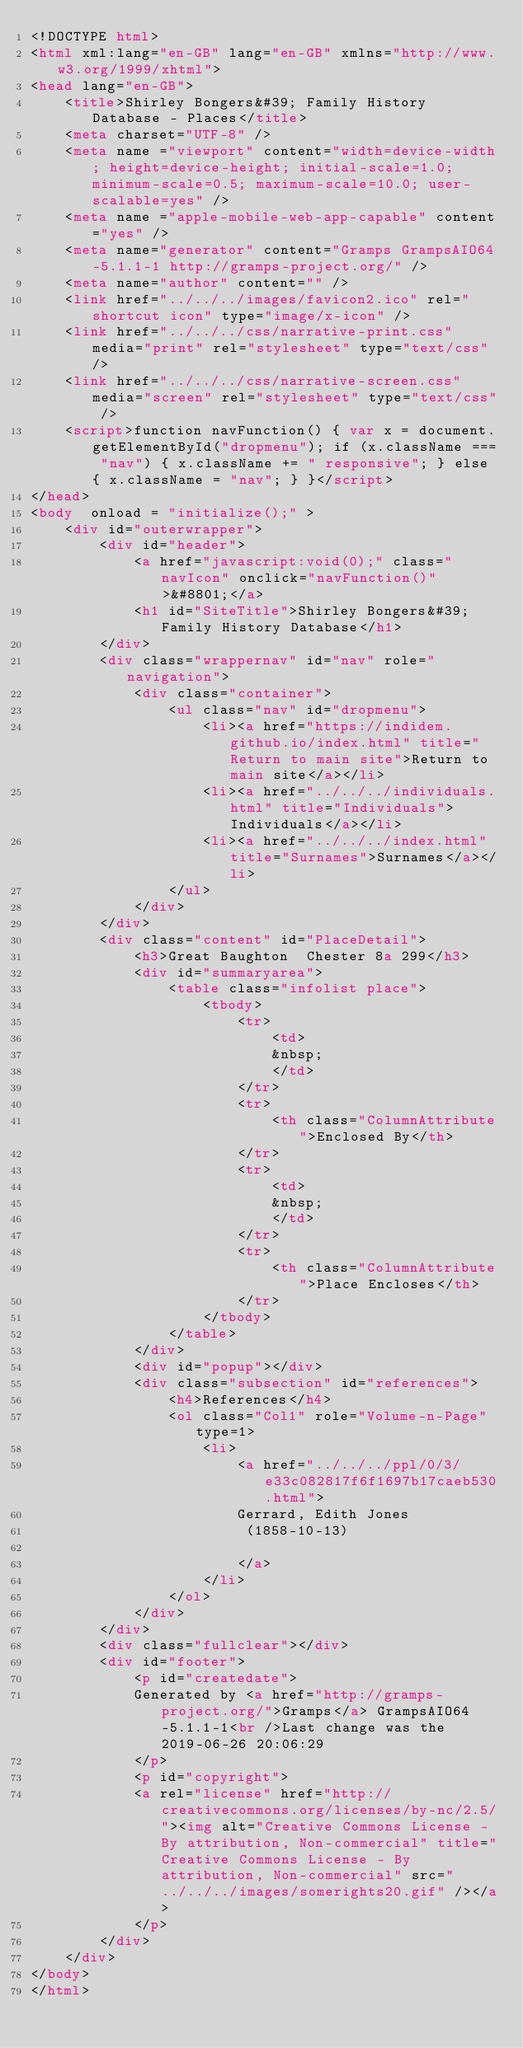Convert code to text. <code><loc_0><loc_0><loc_500><loc_500><_HTML_><!DOCTYPE html>
<html xml:lang="en-GB" lang="en-GB" xmlns="http://www.w3.org/1999/xhtml">
<head lang="en-GB">
	<title>Shirley Bongers&#39; Family History Database - Places</title>
	<meta charset="UTF-8" />
	<meta name ="viewport" content="width=device-width; height=device-height; initial-scale=1.0; minimum-scale=0.5; maximum-scale=10.0; user-scalable=yes" />
	<meta name ="apple-mobile-web-app-capable" content="yes" />
	<meta name="generator" content="Gramps GrampsAIO64-5.1.1-1 http://gramps-project.org/" />
	<meta name="author" content="" />
	<link href="../../../images/favicon2.ico" rel="shortcut icon" type="image/x-icon" />
	<link href="../../../css/narrative-print.css" media="print" rel="stylesheet" type="text/css" />
	<link href="../../../css/narrative-screen.css" media="screen" rel="stylesheet" type="text/css" />
	<script>function navFunction() { var x = document.getElementById("dropmenu"); if (x.className === "nav") { x.className += " responsive"; } else { x.className = "nav"; } }</script>
</head>
<body  onload = "initialize();" >
	<div id="outerwrapper">
		<div id="header">
			<a href="javascript:void(0);" class="navIcon" onclick="navFunction()">&#8801;</a>
			<h1 id="SiteTitle">Shirley Bongers&#39; Family History Database</h1>
		</div>
		<div class="wrappernav" id="nav" role="navigation">
			<div class="container">
				<ul class="nav" id="dropmenu">
					<li><a href="https://indidem.github.io/index.html" title="Return to main site">Return to main site</a></li>
					<li><a href="../../../individuals.html" title="Individuals">Individuals</a></li>
					<li><a href="../../../index.html" title="Surnames">Surnames</a></li>
				</ul>
			</div>
		</div>
		<div class="content" id="PlaceDetail">
			<h3>Great Baughton  Chester 8a 299</h3>
			<div id="summaryarea">
				<table class="infolist place">
					<tbody>
						<tr>
							<td>
							&nbsp;
							</td>
						</tr>
						<tr>
							<th class="ColumnAttribute">Enclosed By</th>
						</tr>
						<tr>
							<td>
							&nbsp;
							</td>
						</tr>
						<tr>
							<th class="ColumnAttribute">Place Encloses</th>
						</tr>
					</tbody>
				</table>
			</div>
			<div id="popup"></div>
			<div class="subsection" id="references">
				<h4>References</h4>
				<ol class="Col1" role="Volume-n-Page" type=1>
					<li>
						<a href="../../../ppl/0/3/e33c082817f6f1697b17caeb530.html">
						Gerrard, Edith Jones
						 (1858-10-13) 
						
						</a>
					</li>
				</ol>
			</div>
		</div>
		<div class="fullclear"></div>
		<div id="footer">
			<p id="createdate">
			Generated by <a href="http://gramps-project.org/">Gramps</a> GrampsAIO64-5.1.1-1<br />Last change was the 2019-06-26 20:06:29
			</p>
			<p id="copyright">
			<a rel="license" href="http://creativecommons.org/licenses/by-nc/2.5/"><img alt="Creative Commons License - By attribution, Non-commercial" title="Creative Commons License - By attribution, Non-commercial" src="../../../images/somerights20.gif" /></a>
			</p>
		</div>
	</div>
</body>
</html>
</code> 